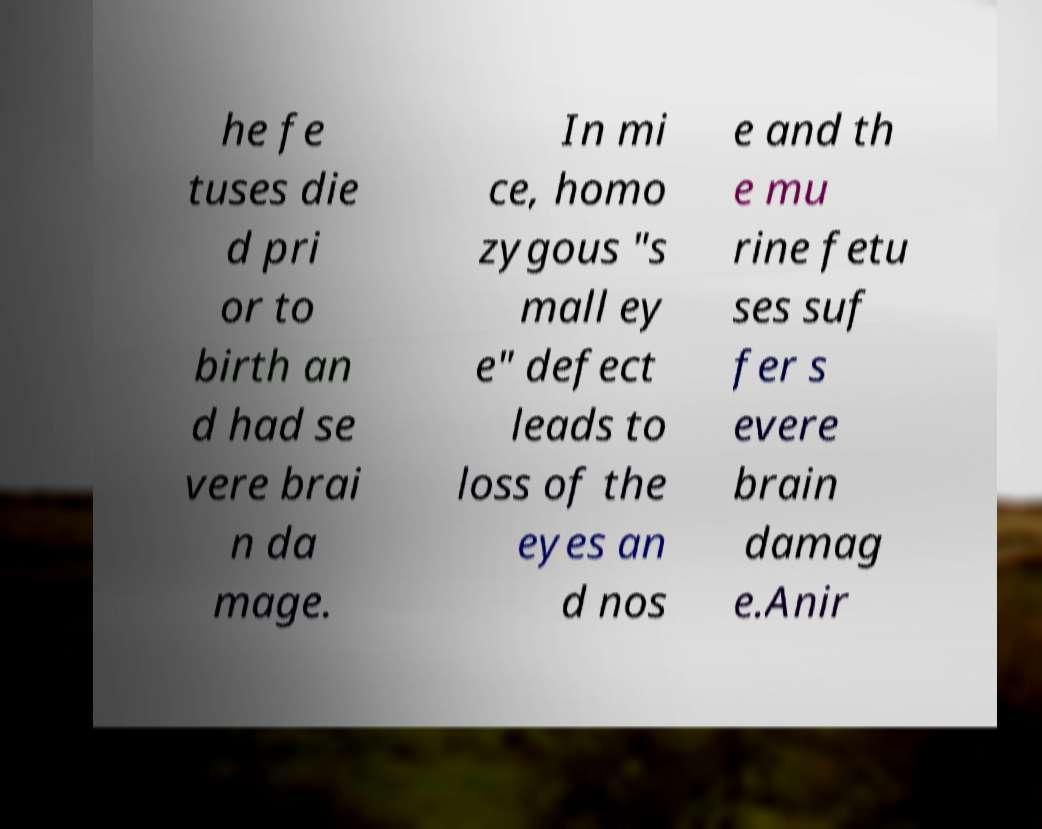What messages or text are displayed in this image? I need them in a readable, typed format. he fe tuses die d pri or to birth an d had se vere brai n da mage. In mi ce, homo zygous "s mall ey e" defect leads to loss of the eyes an d nos e and th e mu rine fetu ses suf fer s evere brain damag e.Anir 